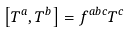<formula> <loc_0><loc_0><loc_500><loc_500>\left [ T ^ { a } , T ^ { b } \right ] = f ^ { a b c } T ^ { c }</formula> 